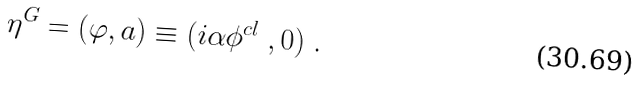Convert formula to latex. <formula><loc_0><loc_0><loc_500><loc_500>\eta ^ { G } = ( \varphi , a ) \equiv ( i \alpha \phi ^ { c l } \ , 0 ) \ .</formula> 